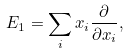<formula> <loc_0><loc_0><loc_500><loc_500>E _ { 1 } = \sum _ { i } x _ { i } \frac { \partial } { \partial x _ { i } } ,</formula> 